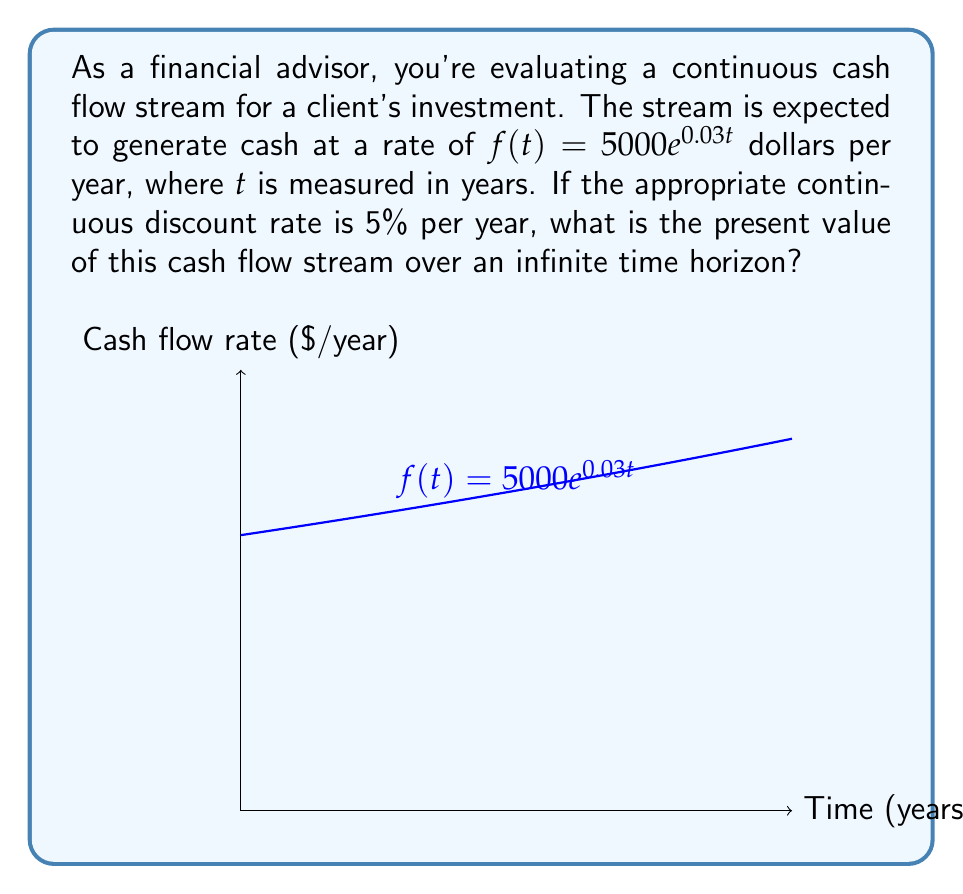Help me with this question. Let's approach this step-by-step:

1) The present value of a continuous cash flow stream is given by the formula:

   $$PV = \int_0^{\infty} f(t)e^{-rt} dt$$

   where $f(t)$ is the cash flow rate function and $r$ is the discount rate.

2) In this case, $f(t) = 5000e^{0.03t}$ and $r = 0.05$.

3) Substituting these into the formula:

   $$PV = \int_0^{\infty} 5000e^{0.03t}e^{-0.05t} dt$$

4) Simplify the integrand:

   $$PV = \int_0^{\infty} 5000e^{-0.02t} dt$$

5) Integrate:

   $$PV = 5000 \left[-\frac{1}{0.02}e^{-0.02t}\right]_0^{\infty}$$

6) Evaluate the limits:

   $$PV = 5000 \left(0 - \left(-\frac{1}{0.02}\right)\right)$$

7) Simplify:

   $$PV = 5000 \cdot \frac{1}{0.02} = \frac{5000}{0.02} = 250,000$$

Therefore, the present value of the cash flow stream is $250,000.
Answer: $250,000 